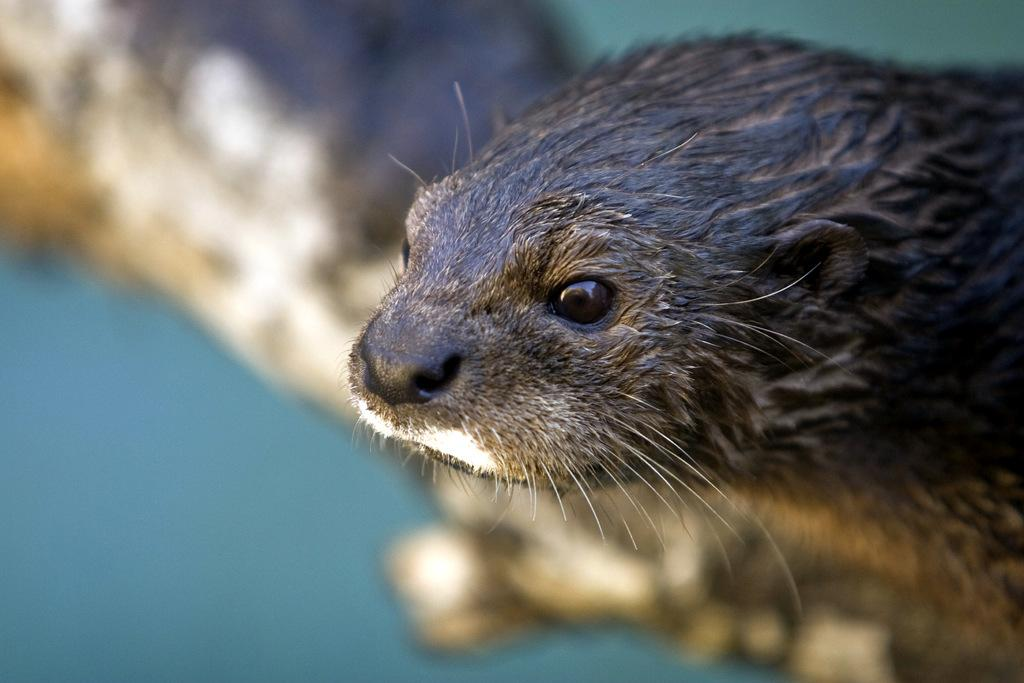What is the main subject of the image? The main subject of the image is an animal's face. Can you describe the color of the animal's face? The animal's face is black in color. What type of business is being conducted in the image? There is no indication of any business activity in the image, as it is a zoomed-in picture of an animal's face. What type of linen is draped over the animal's face in the image? There is no linen present in the image; it is a picture of an animal's face without any additional elements. 